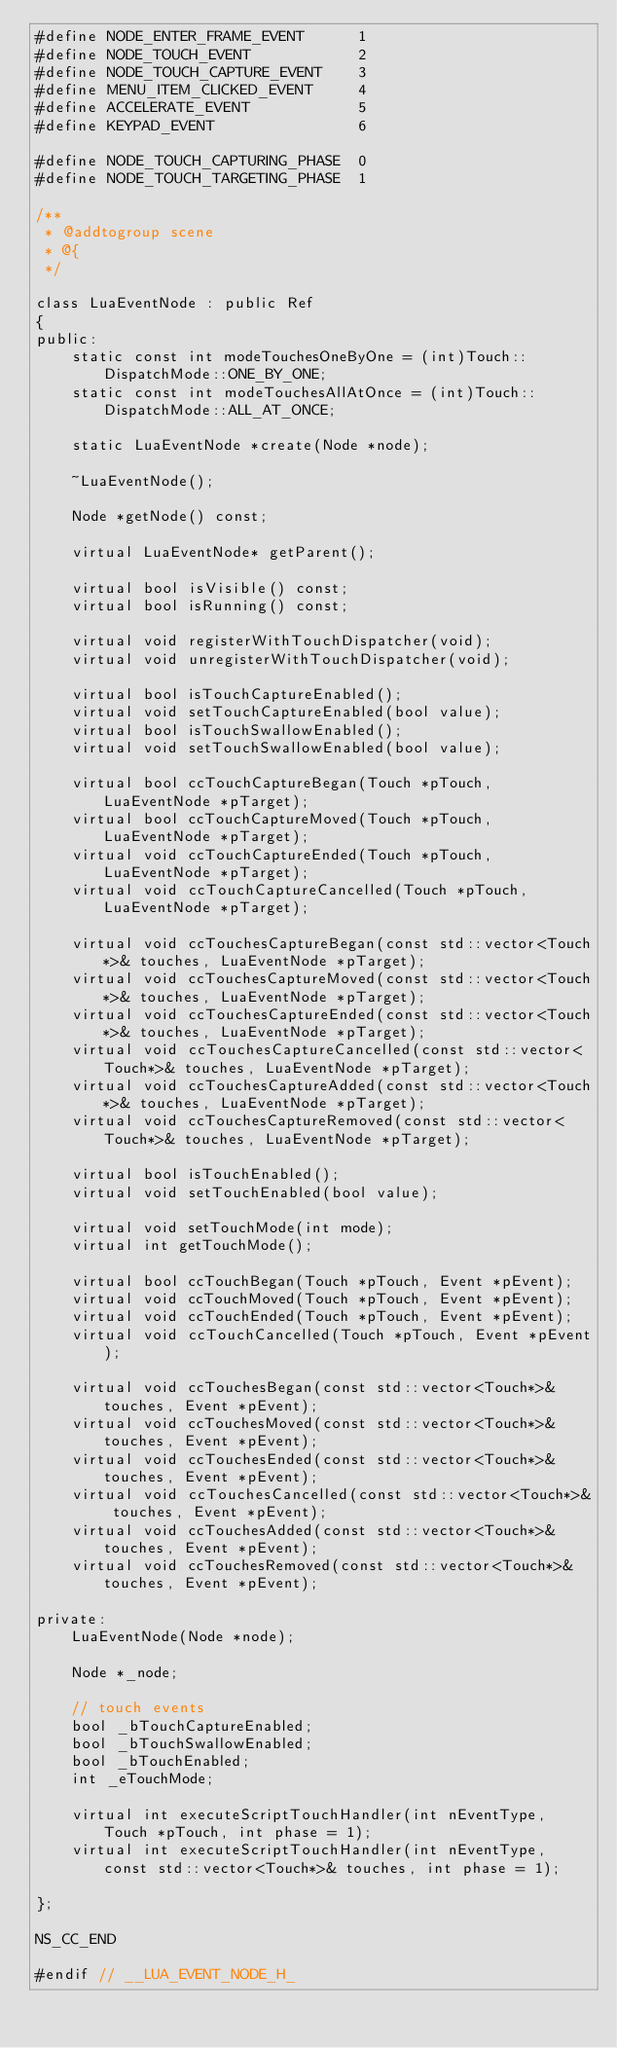<code> <loc_0><loc_0><loc_500><loc_500><_C_>#define NODE_ENTER_FRAME_EVENT      1
#define NODE_TOUCH_EVENT            2
#define NODE_TOUCH_CAPTURE_EVENT    3
#define MENU_ITEM_CLICKED_EVENT     4
#define ACCELERATE_EVENT            5
#define KEYPAD_EVENT                6

#define NODE_TOUCH_CAPTURING_PHASE  0
#define NODE_TOUCH_TARGETING_PHASE  1

/**
 * @addtogroup scene
 * @{
 */

class LuaEventNode : public Ref
{
public:
    static const int modeTouchesOneByOne = (int)Touch::DispatchMode::ONE_BY_ONE;
    static const int modeTouchesAllAtOnce = (int)Touch::DispatchMode::ALL_AT_ONCE;
    
    static LuaEventNode *create(Node *node);

    ~LuaEventNode();

    Node *getNode() const;

    virtual LuaEventNode* getParent();
    
    virtual bool isVisible() const;
    virtual bool isRunning() const;
    
    virtual void registerWithTouchDispatcher(void);
    virtual void unregisterWithTouchDispatcher(void);
    
    virtual bool isTouchCaptureEnabled();
    virtual void setTouchCaptureEnabled(bool value);
    virtual bool isTouchSwallowEnabled();
    virtual void setTouchSwallowEnabled(bool value);
    
    virtual bool ccTouchCaptureBegan(Touch *pTouch, LuaEventNode *pTarget);
    virtual bool ccTouchCaptureMoved(Touch *pTouch, LuaEventNode *pTarget);
    virtual void ccTouchCaptureEnded(Touch *pTouch, LuaEventNode *pTarget);
    virtual void ccTouchCaptureCancelled(Touch *pTouch, LuaEventNode *pTarget);
    
    virtual void ccTouchesCaptureBegan(const std::vector<Touch*>& touches, LuaEventNode *pTarget);
    virtual void ccTouchesCaptureMoved(const std::vector<Touch*>& touches, LuaEventNode *pTarget);
    virtual void ccTouchesCaptureEnded(const std::vector<Touch*>& touches, LuaEventNode *pTarget);
    virtual void ccTouchesCaptureCancelled(const std::vector<Touch*>& touches, LuaEventNode *pTarget);
    virtual void ccTouchesCaptureAdded(const std::vector<Touch*>& touches, LuaEventNode *pTarget);
    virtual void ccTouchesCaptureRemoved(const std::vector<Touch*>& touches, LuaEventNode *pTarget);
    
    virtual bool isTouchEnabled();
    virtual void setTouchEnabled(bool value);
    
    virtual void setTouchMode(int mode);
    virtual int getTouchMode();
    
    virtual bool ccTouchBegan(Touch *pTouch, Event *pEvent);
    virtual void ccTouchMoved(Touch *pTouch, Event *pEvent);
    virtual void ccTouchEnded(Touch *pTouch, Event *pEvent);
    virtual void ccTouchCancelled(Touch *pTouch, Event *pEvent);
    
    virtual void ccTouchesBegan(const std::vector<Touch*>& touches, Event *pEvent);
    virtual void ccTouchesMoved(const std::vector<Touch*>& touches, Event *pEvent);
    virtual void ccTouchesEnded(const std::vector<Touch*>& touches, Event *pEvent);
    virtual void ccTouchesCancelled(const std::vector<Touch*>& touches, Event *pEvent);
    virtual void ccTouchesAdded(const std::vector<Touch*>& touches, Event *pEvent);
    virtual void ccTouchesRemoved(const std::vector<Touch*>& touches, Event *pEvent);

private:
    LuaEventNode(Node *node);

    Node *_node;
    
    // touch events
    bool _bTouchCaptureEnabled;
    bool _bTouchSwallowEnabled;
    bool _bTouchEnabled;
    int _eTouchMode;

    virtual int executeScriptTouchHandler(int nEventType, Touch *pTouch, int phase = 1);
    virtual int executeScriptTouchHandler(int nEventType, const std::vector<Touch*>& touches, int phase = 1);
    
};

NS_CC_END

#endif // __LUA_EVENT_NODE_H_
</code> 